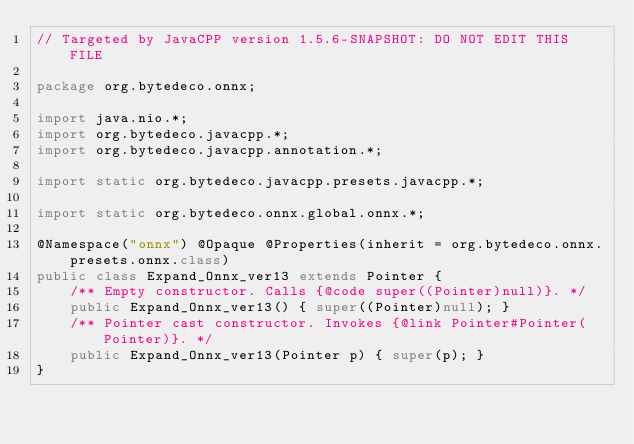<code> <loc_0><loc_0><loc_500><loc_500><_Java_>// Targeted by JavaCPP version 1.5.6-SNAPSHOT: DO NOT EDIT THIS FILE

package org.bytedeco.onnx;

import java.nio.*;
import org.bytedeco.javacpp.*;
import org.bytedeco.javacpp.annotation.*;

import static org.bytedeco.javacpp.presets.javacpp.*;

import static org.bytedeco.onnx.global.onnx.*;

@Namespace("onnx") @Opaque @Properties(inherit = org.bytedeco.onnx.presets.onnx.class)
public class Expand_Onnx_ver13 extends Pointer {
    /** Empty constructor. Calls {@code super((Pointer)null)}. */
    public Expand_Onnx_ver13() { super((Pointer)null); }
    /** Pointer cast constructor. Invokes {@link Pointer#Pointer(Pointer)}. */
    public Expand_Onnx_ver13(Pointer p) { super(p); }
}
</code> 